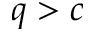Convert formula to latex. <formula><loc_0><loc_0><loc_500><loc_500>q > c</formula> 